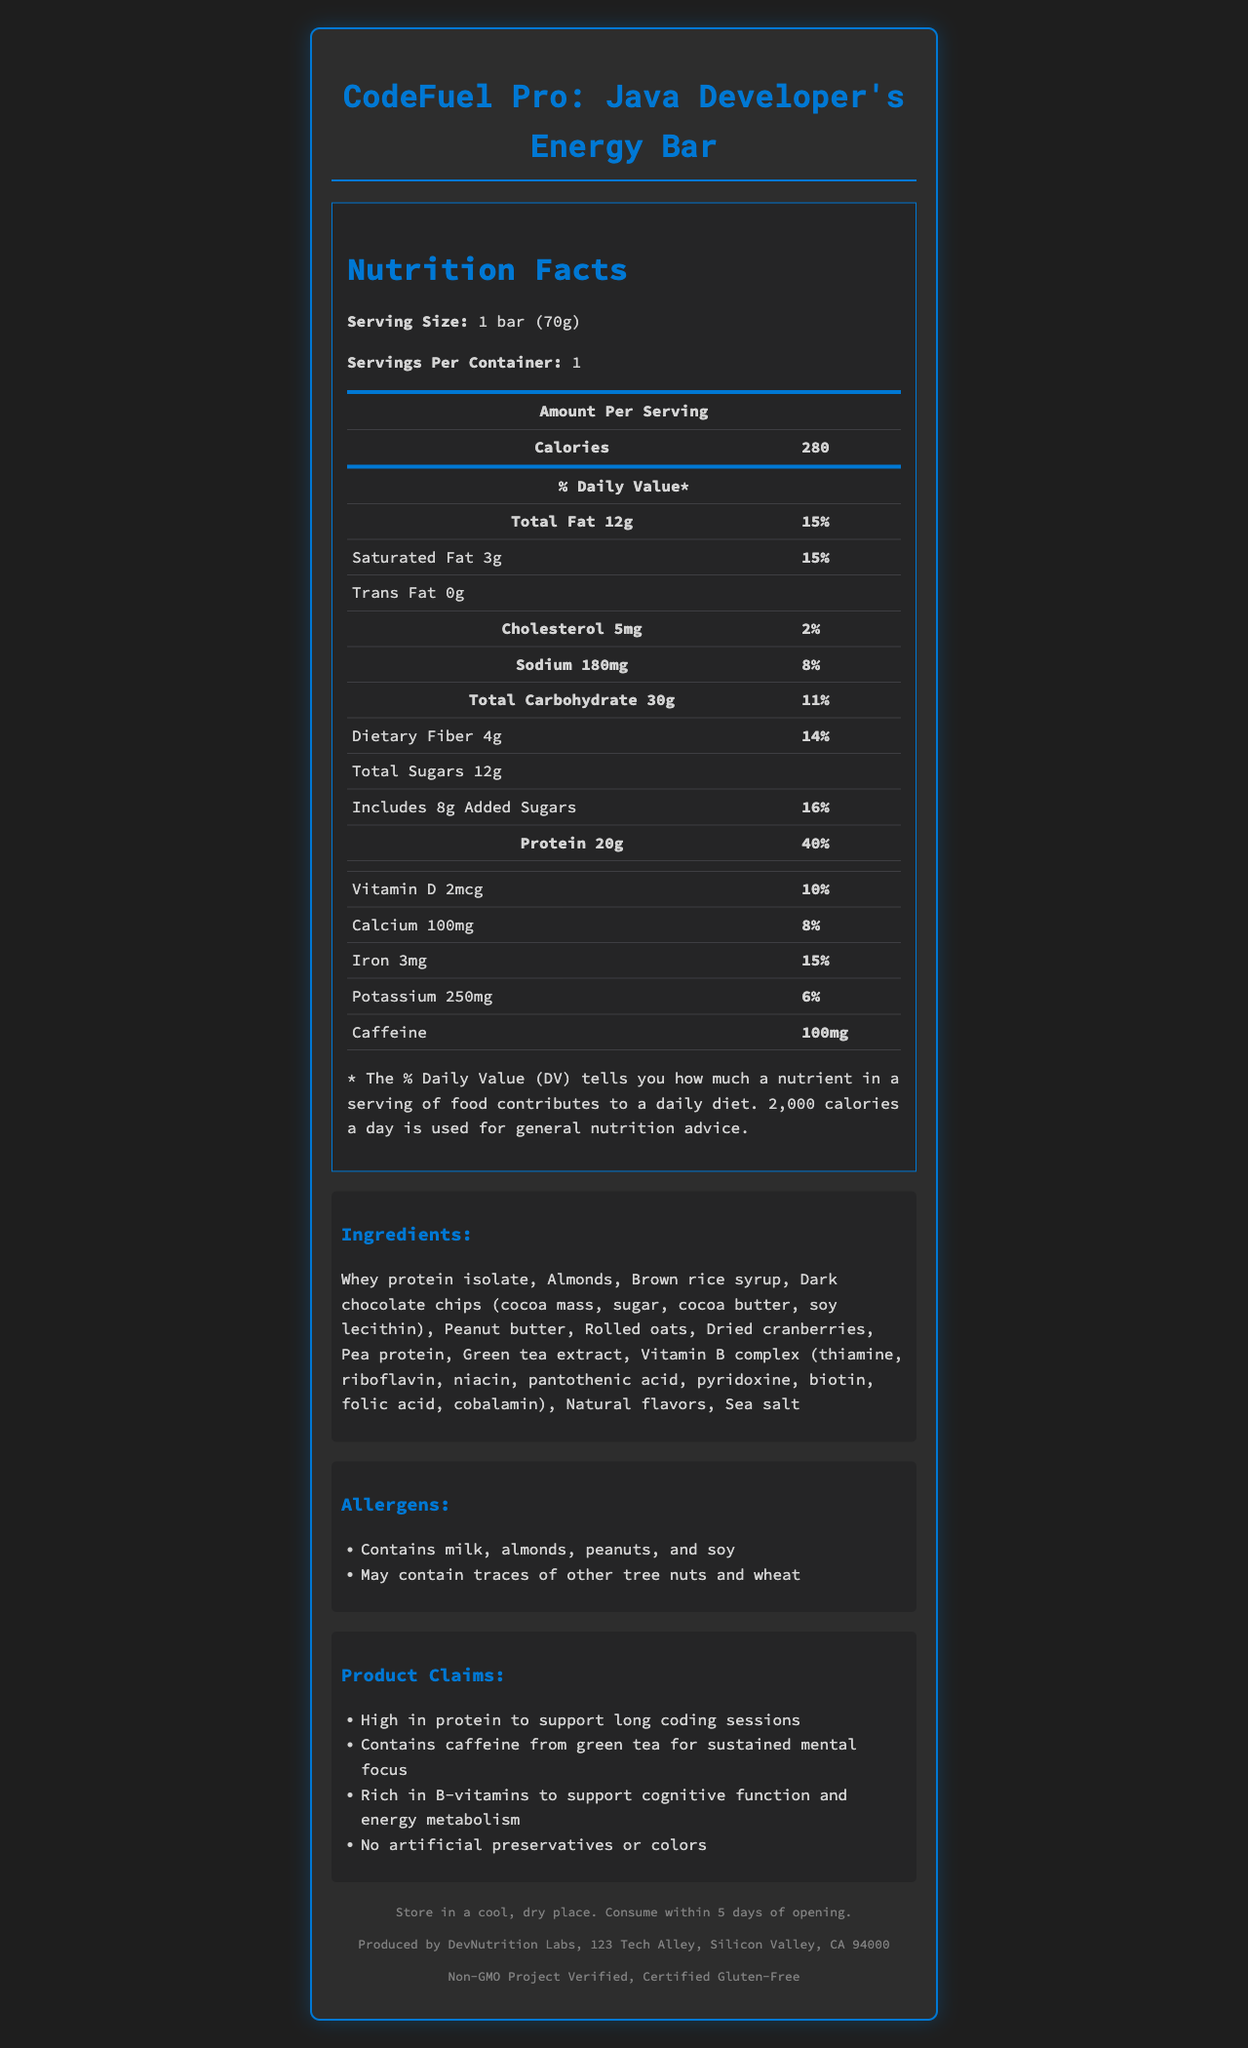what is the product name? The product name is stated at the very beginning and in the title.
Answer: CodeFuel Pro: Java Developer's Energy Bar what is the serving size of the energy bar? The serving size is listed under the "Nutrition Facts" section at the start of the document.
Answer: 1 bar (70g) how many calories are in one serving? The calories per serving are listed right under the "Amount Per Serving" section in bold.
Answer: 280 what is the percentage of daily value for protein in one serving? The percentage of daily value for protein is listed next to the protein amount in the "Amount Per Serving" section.
Answer: 40% how much caffeine does the energy bar contain? The amount of caffeine is listed in the nutrition facts table at the end.
Answer: 100mg What percentage of the daily value does the added sugars provide? A. 10% B. 12% C. 13% D. 16% The daily value for added sugars is given as 16% in the provided information.
Answer: D. 16% Which of the following vitamins is included in the energy bar? A. Vitamin C B. Vitamin D C. Vitamin E D. Vitamin K Only Vitamin D is listed in the nutrition facts section.
Answer: B. Vitamin D Does the energy bar contain artificial preservatives or colors? One of the claims states that the product contains "No artificial preservatives or colors".
Answer: No Is this energy bar certified gluten-free? The footer of the document includes the certification details, including "Certified Gluten-Free".
Answer: Yes Summarize the nutritional content and main features of the energy bar. This energy bar provides substantial protein, moderate calories, and a good blend of vitamins and minerals while avoiding artificial additives. It is designed for developers and includes certifications for health and safety.
Answer: The CodeFuel Pro: Java Developer's Energy Bar offers high-protein content (20g, 40% daily value) with moderate calories (280 per bar). It is also rich in vitamins and minerals such as Vitamin D, calcium, iron, and potassium. The bar includes caffeine for mental focus, primarily sourced from ingredients like whey protein isolate, almonds, dark chocolate chips, and green tea extract. It boasts no artificial preservatives or colors and is gluten-free and non-GMO certified, designed to support long coding sessions. What is the weight of the bar? The exact weight of the bar isn't explicitly listed; only the serving size '1 bar (70g)' is mentioned, but it isn’t clear if that is its weight.
Answer: Not enough information 